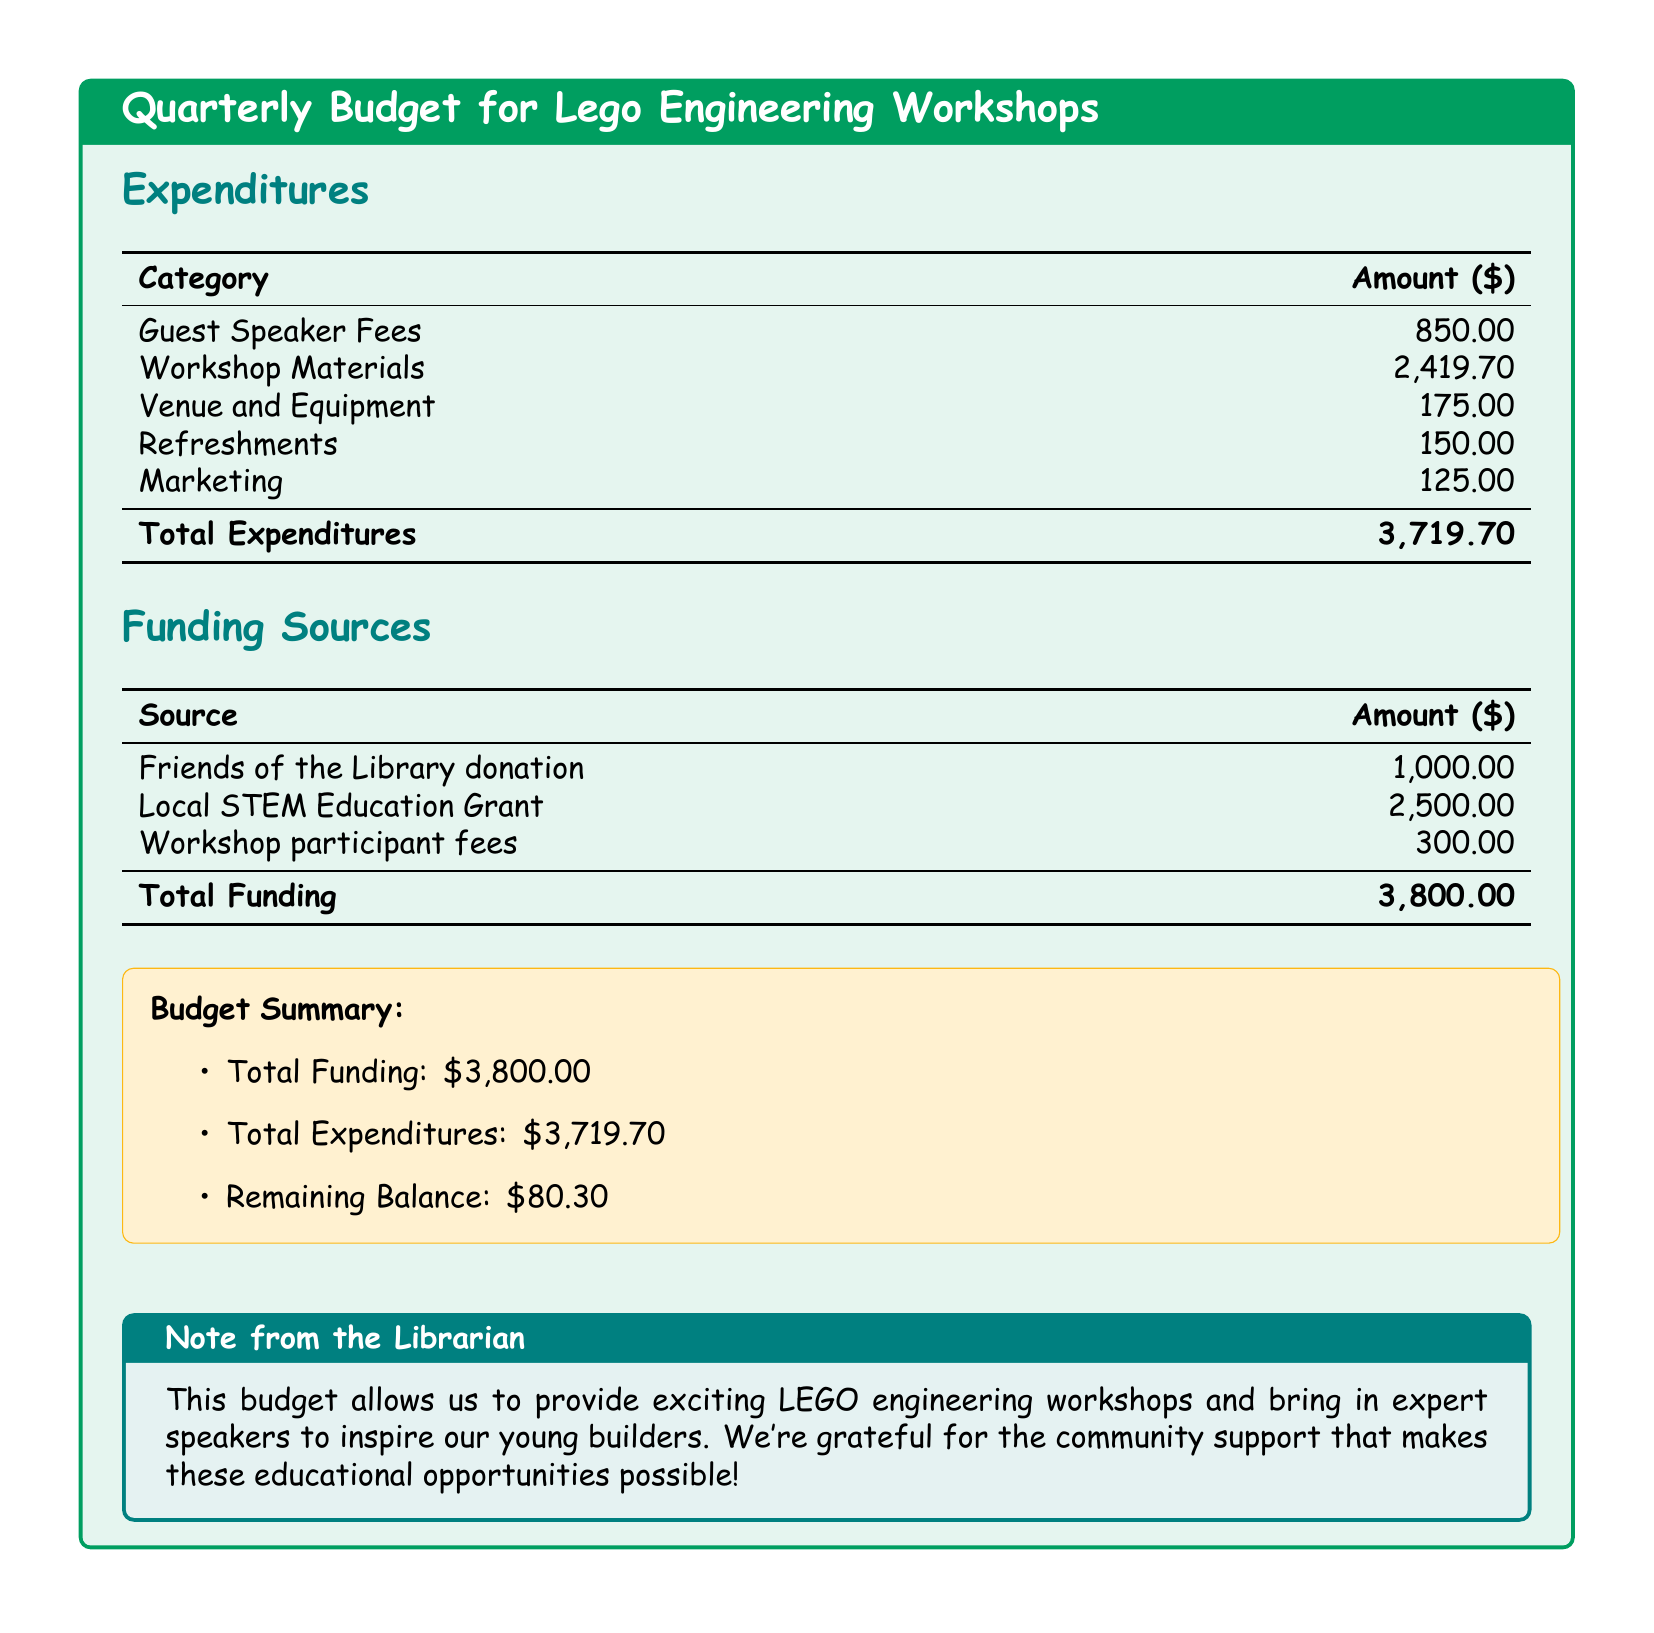what is the total amount spent on workshop materials? The total amount spent on workshop materials is directly provided in the expenditures section of the document.
Answer: 2419.70 how much did the guest speaker fees cost? The amount for guest speaker fees is listed in the expenditures table.
Answer: 850.00 what is the amount of funding received from the Local STEM Education Grant? The amount received from the Local STEM Education Grant is given in the funding sources table.
Answer: 2500.00 what is the total balance remaining after expenditures? The remaining balance is calculated as total funding minus total expenditures, as summarized in the budget summary.
Answer: 80.30 how much was spent on refreshments? The amount spent on refreshments is specified in the expenditures section.
Answer: 150.00 which organization provided a donation for the workshops? The organization that provided a donation is listed in the funding sources section of the document.
Answer: Friends of the Library what is the total amount of funding? The total funding is detailed in the funding sources table and represents the sum of all funding sources.
Answer: 3800.00 how much was allocated for marketing? The allocated amount for marketing can be found in the expenditures section of the document.
Answer: 125.00 what is the total cost for venue and equipment? The total cost for venue and equipment is mentioned in the expenditures section.
Answer: 175.00 